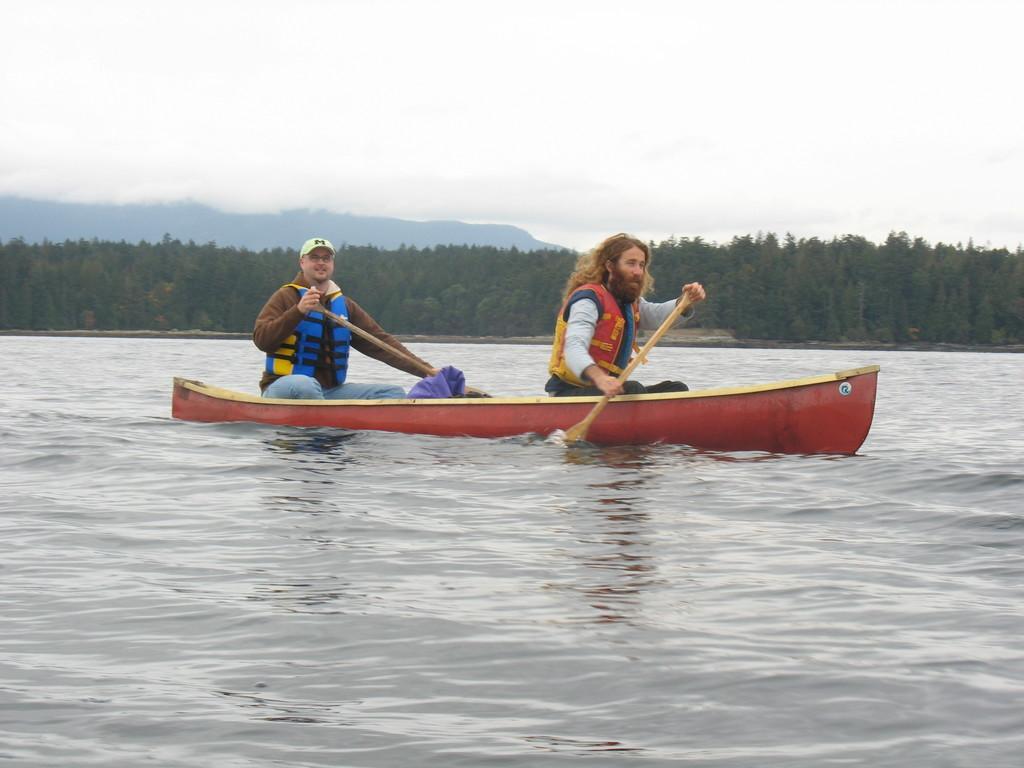How would you summarize this image in a sentence or two? In the image we can see the boat in the water. In the boat there are two people sitting, wearing clothes and holding the paddle in their hands. The left side man is wearing the cap and spectacles. There are trees, mountain and the sky. 